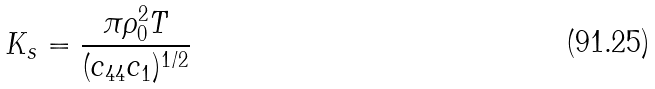Convert formula to latex. <formula><loc_0><loc_0><loc_500><loc_500>K _ { s } = \frac { \pi \rho _ { 0 } ^ { 2 } T } { ( c _ { 4 4 } c _ { 1 } ) ^ { 1 / 2 } }</formula> 